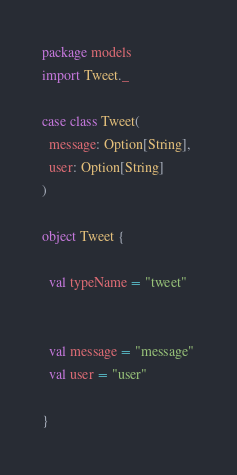<code> <loc_0><loc_0><loc_500><loc_500><_Scala_>package models
import Tweet._

case class Tweet(
  message: Option[String], 
  user: Option[String]
)

object Tweet {

  val typeName = "tweet"


  val message = "message"
  val user = "user"

}</code> 